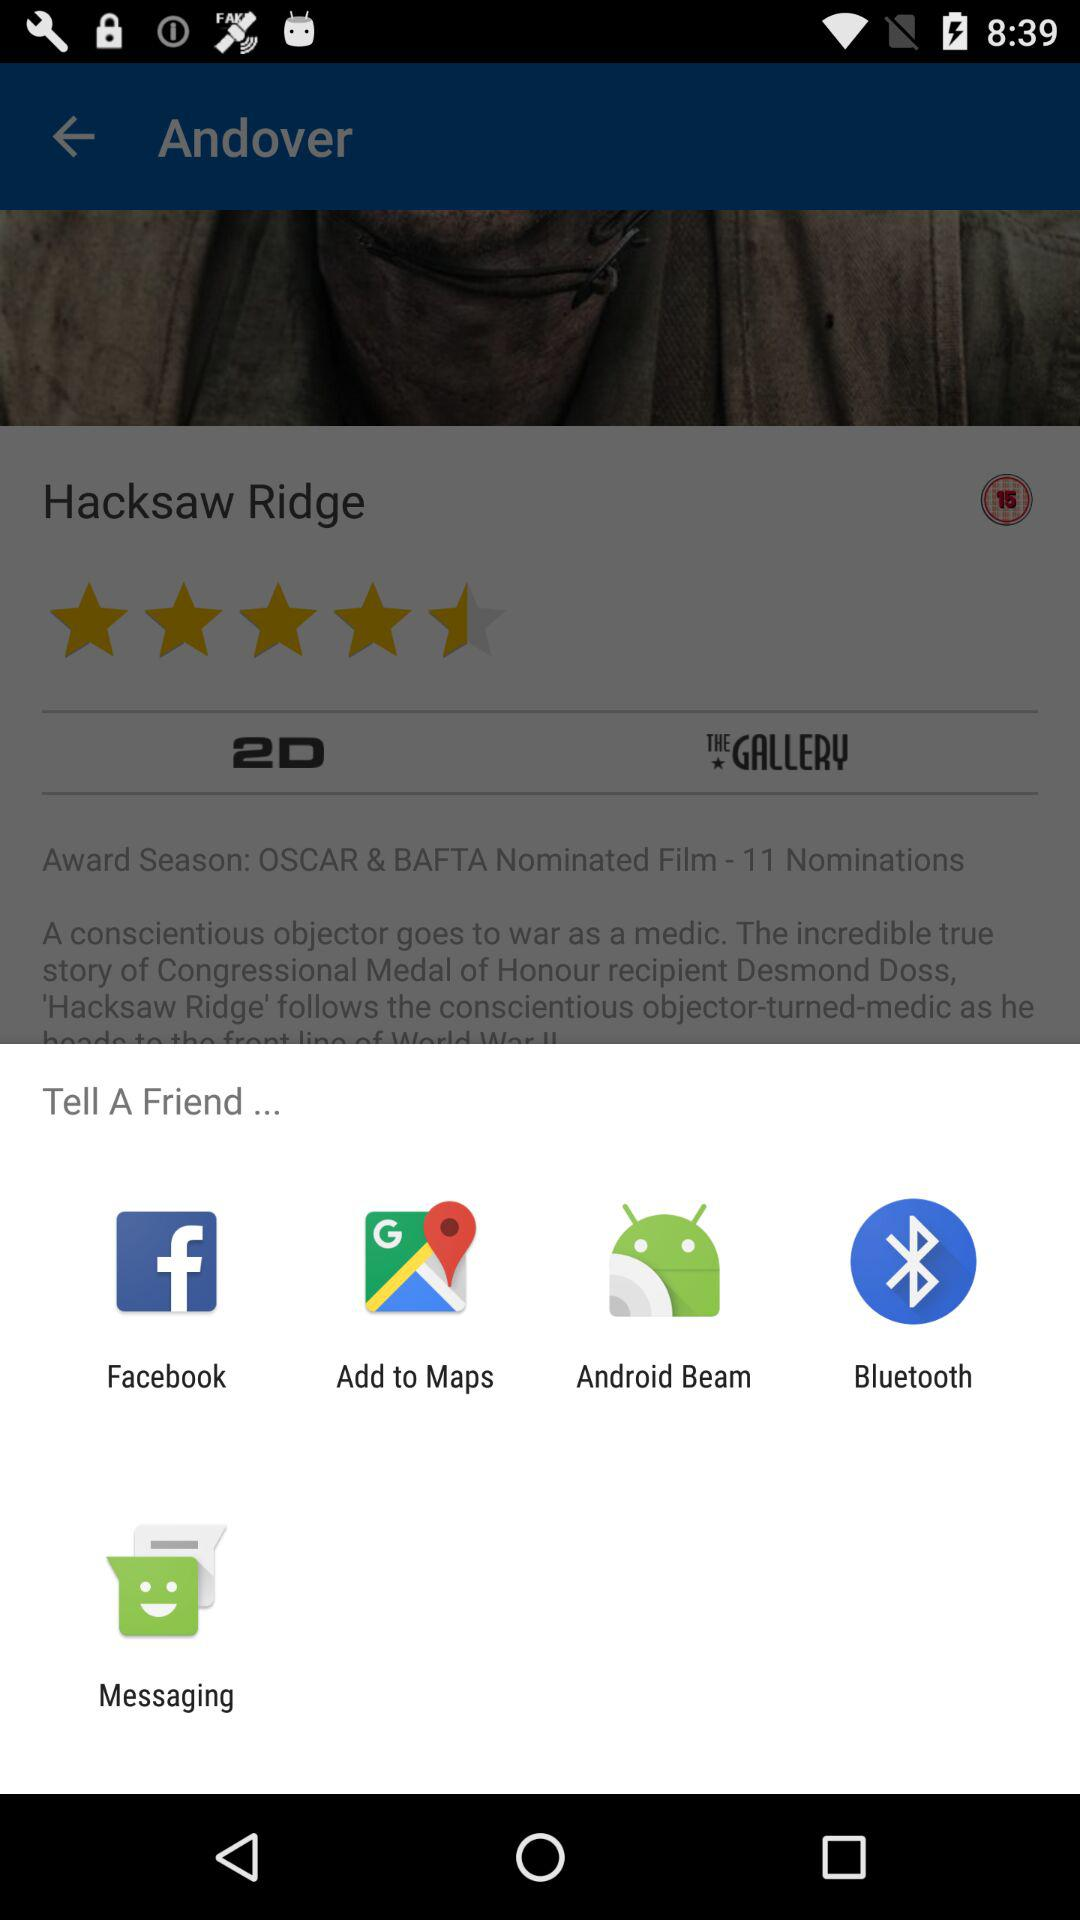What accounts can I use to tell a friend? You can use "Facebook", "Add to Maps", "Android Beam", "Bluetooth" and "Messaging". 